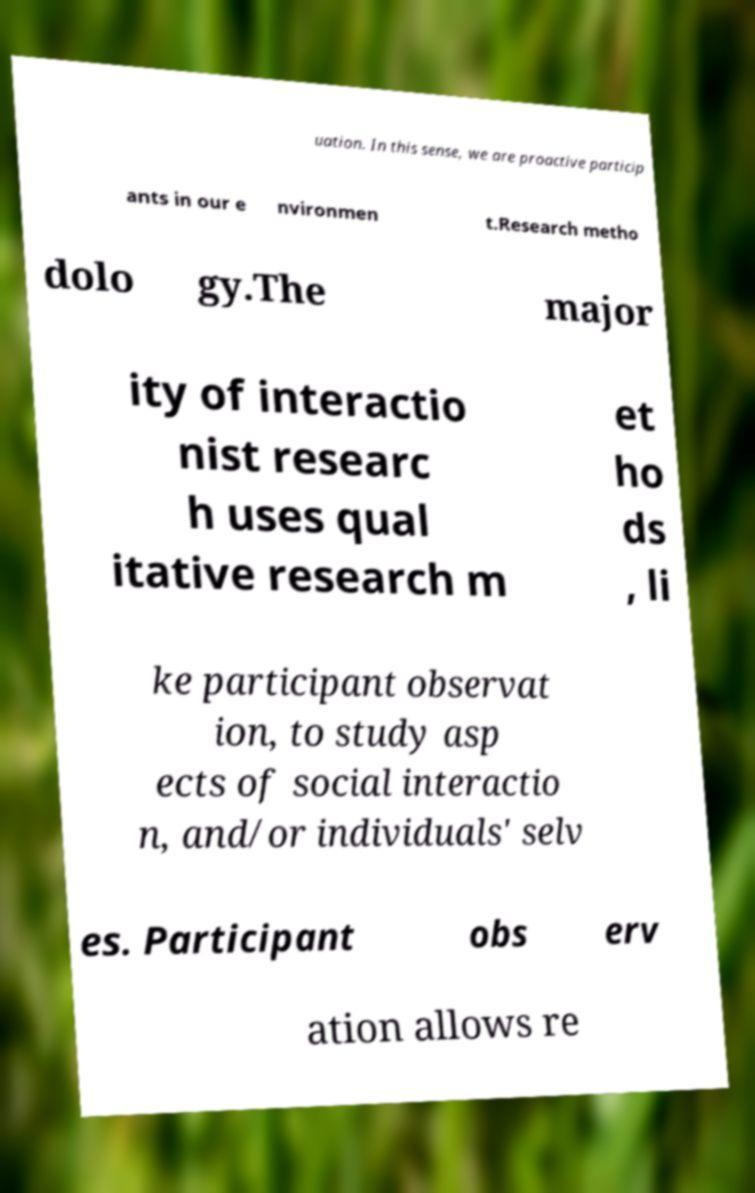Can you read and provide the text displayed in the image?This photo seems to have some interesting text. Can you extract and type it out for me? uation. In this sense, we are proactive particip ants in our e nvironmen t.Research metho dolo gy.The major ity of interactio nist researc h uses qual itative research m et ho ds , li ke participant observat ion, to study asp ects of social interactio n, and/or individuals' selv es. Participant obs erv ation allows re 